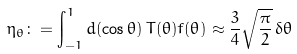Convert formula to latex. <formula><loc_0><loc_0><loc_500><loc_500>\eta _ { \theta } \colon = \int _ { - 1 } ^ { 1 } d ( \cos \theta ) \, T ( \theta ) f ( \theta ) \approx \frac { 3 } { 4 } \sqrt { \frac { \pi } { 2 } } \, \delta \theta</formula> 